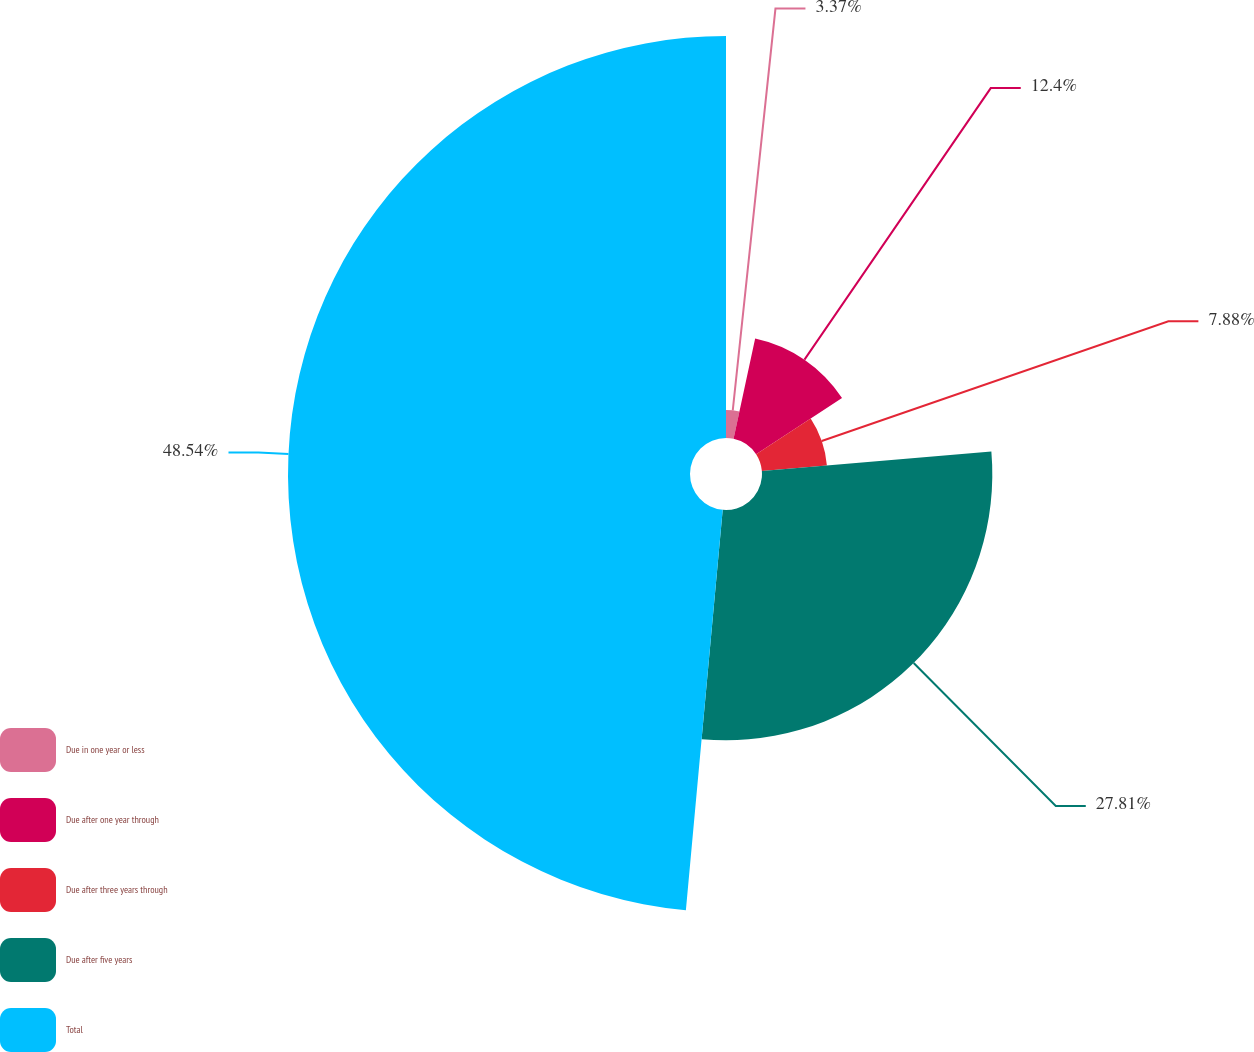<chart> <loc_0><loc_0><loc_500><loc_500><pie_chart><fcel>Due in one year or less<fcel>Due after one year through<fcel>Due after three years through<fcel>Due after five years<fcel>Total<nl><fcel>3.37%<fcel>12.4%<fcel>7.88%<fcel>27.81%<fcel>48.54%<nl></chart> 